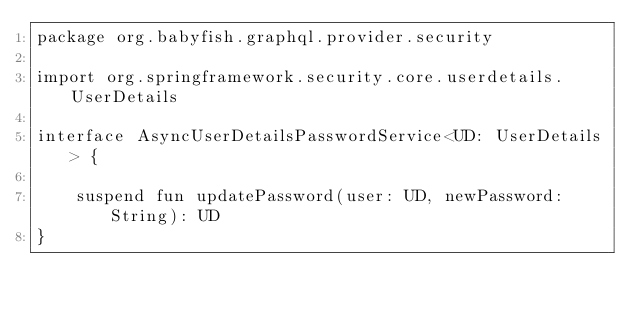<code> <loc_0><loc_0><loc_500><loc_500><_Kotlin_>package org.babyfish.graphql.provider.security

import org.springframework.security.core.userdetails.UserDetails

interface AsyncUserDetailsPasswordService<UD: UserDetails> {

    suspend fun updatePassword(user: UD, newPassword: String): UD
}</code> 